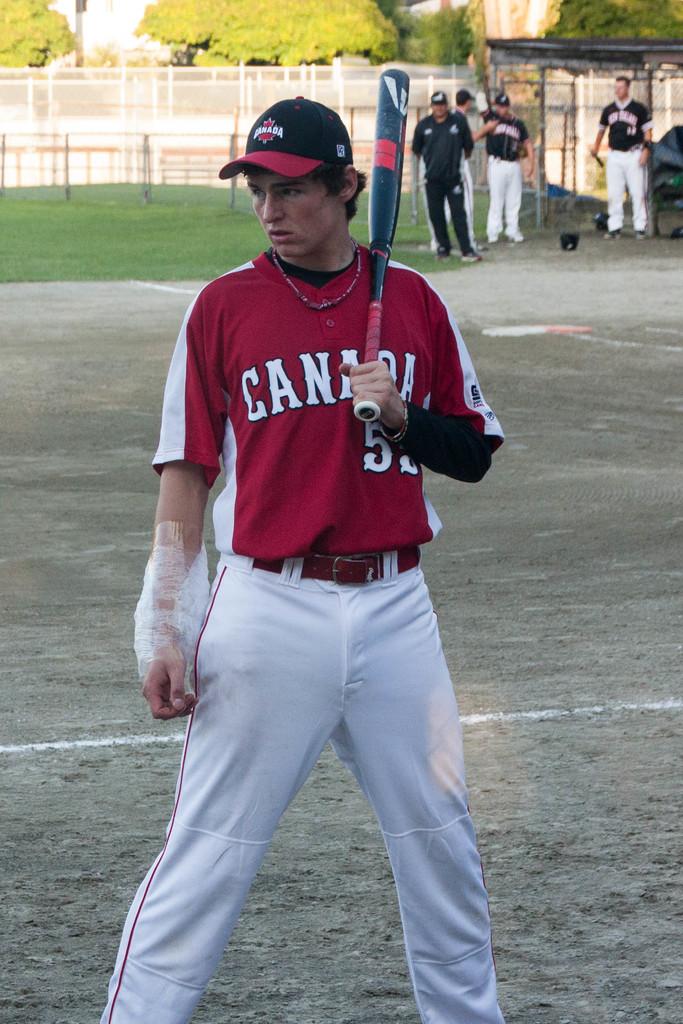What team does he play for?
Your answer should be very brief. Canada. What is the number of the player?
Offer a terse response. 52. 